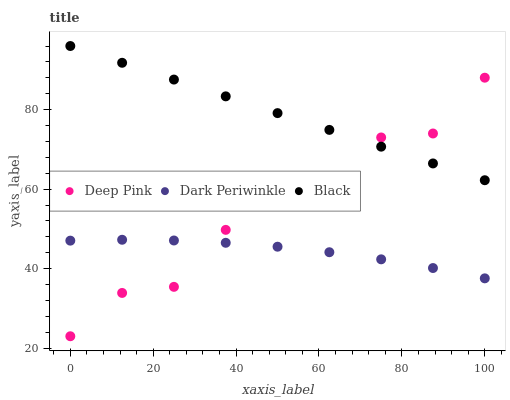Does Dark Periwinkle have the minimum area under the curve?
Answer yes or no. Yes. Does Black have the maximum area under the curve?
Answer yes or no. Yes. Does Black have the minimum area under the curve?
Answer yes or no. No. Does Dark Periwinkle have the maximum area under the curve?
Answer yes or no. No. Is Black the smoothest?
Answer yes or no. Yes. Is Deep Pink the roughest?
Answer yes or no. Yes. Is Dark Periwinkle the smoothest?
Answer yes or no. No. Is Dark Periwinkle the roughest?
Answer yes or no. No. Does Deep Pink have the lowest value?
Answer yes or no. Yes. Does Dark Periwinkle have the lowest value?
Answer yes or no. No. Does Black have the highest value?
Answer yes or no. Yes. Does Dark Periwinkle have the highest value?
Answer yes or no. No. Is Dark Periwinkle less than Black?
Answer yes or no. Yes. Is Black greater than Dark Periwinkle?
Answer yes or no. Yes. Does Black intersect Deep Pink?
Answer yes or no. Yes. Is Black less than Deep Pink?
Answer yes or no. No. Is Black greater than Deep Pink?
Answer yes or no. No. Does Dark Periwinkle intersect Black?
Answer yes or no. No. 